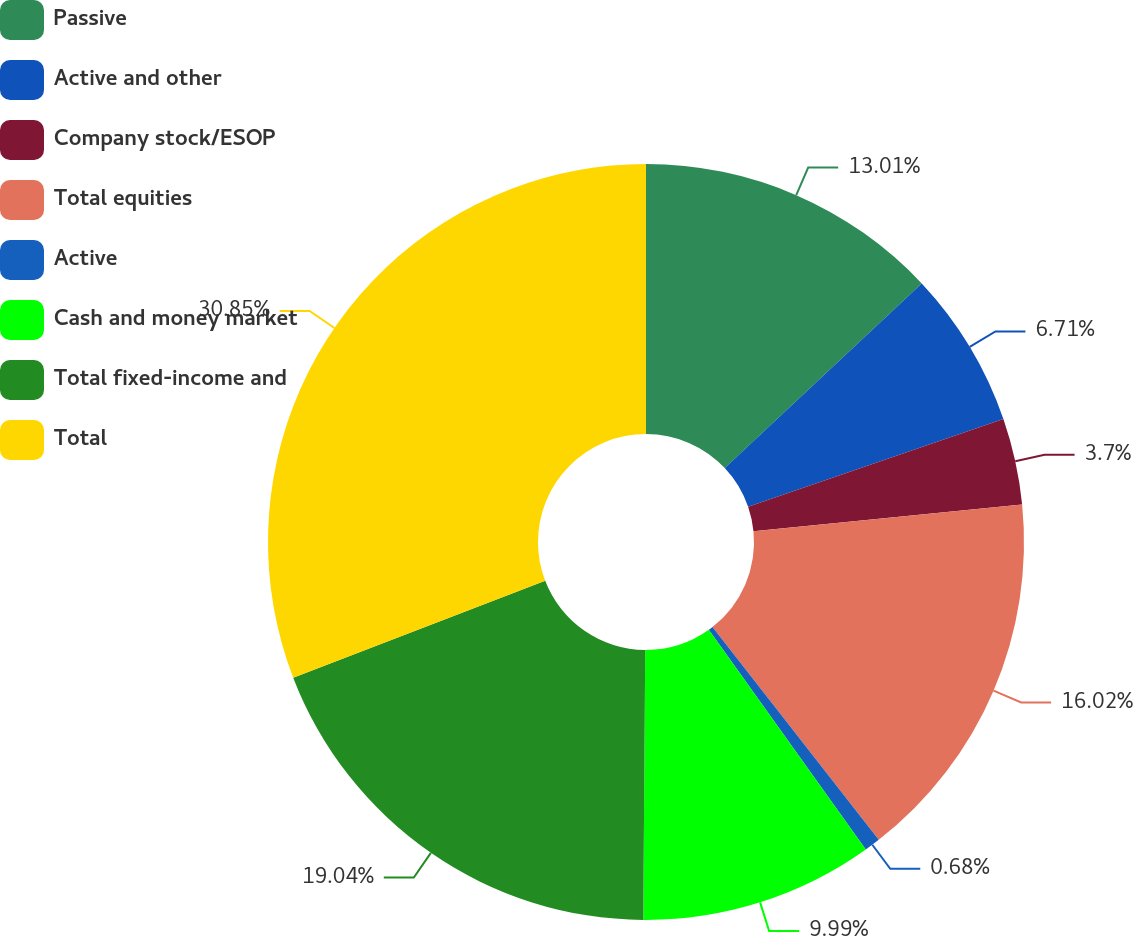<chart> <loc_0><loc_0><loc_500><loc_500><pie_chart><fcel>Passive<fcel>Active and other<fcel>Company stock/ESOP<fcel>Total equities<fcel>Active<fcel>Cash and money market<fcel>Total fixed-income and<fcel>Total<nl><fcel>13.01%<fcel>6.71%<fcel>3.7%<fcel>16.02%<fcel>0.68%<fcel>9.99%<fcel>19.04%<fcel>30.84%<nl></chart> 